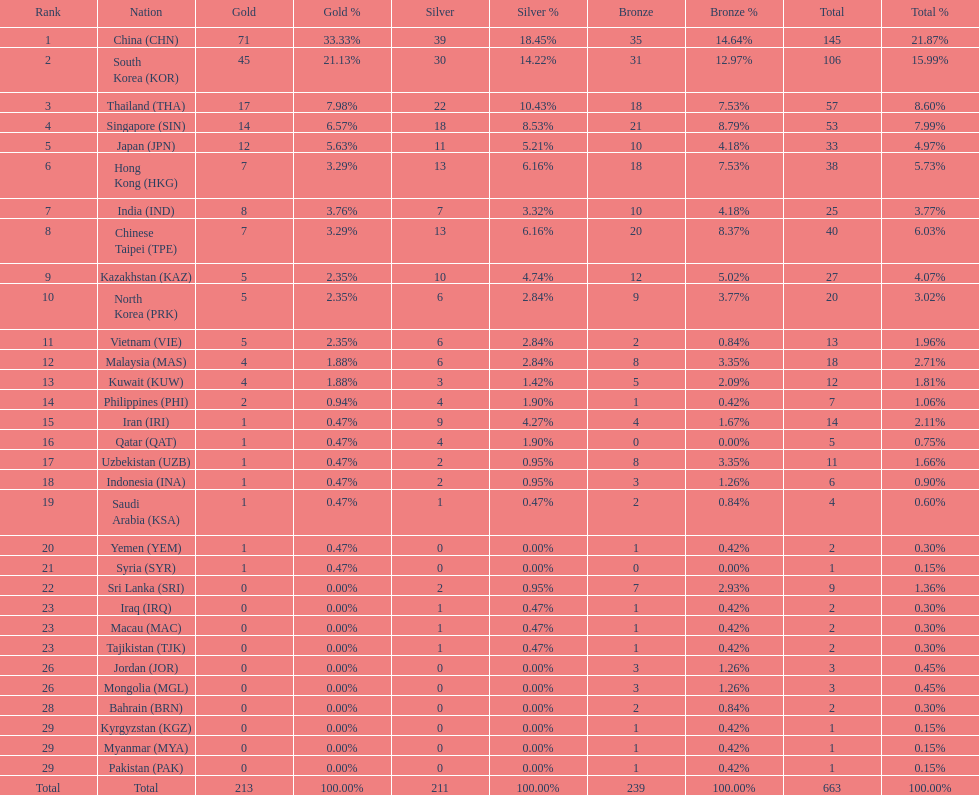How many more gold medals must qatar win before they can earn 12 gold medals? 11. 